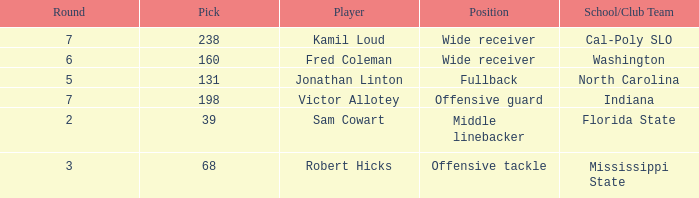Write the full table. {'header': ['Round', 'Pick', 'Player', 'Position', 'School/Club Team'], 'rows': [['7', '238', 'Kamil Loud', 'Wide receiver', 'Cal-Poly SLO'], ['6', '160', 'Fred Coleman', 'Wide receiver', 'Washington'], ['5', '131', 'Jonathan Linton', 'Fullback', 'North Carolina'], ['7', '198', 'Victor Allotey', 'Offensive guard', 'Indiana'], ['2', '39', 'Sam Cowart', 'Middle linebacker', 'Florida State'], ['3', '68', 'Robert Hicks', 'Offensive tackle', 'Mississippi State']]} Which Player has a Round smaller than 5, and a School/Club Team of florida state? Sam Cowart. 